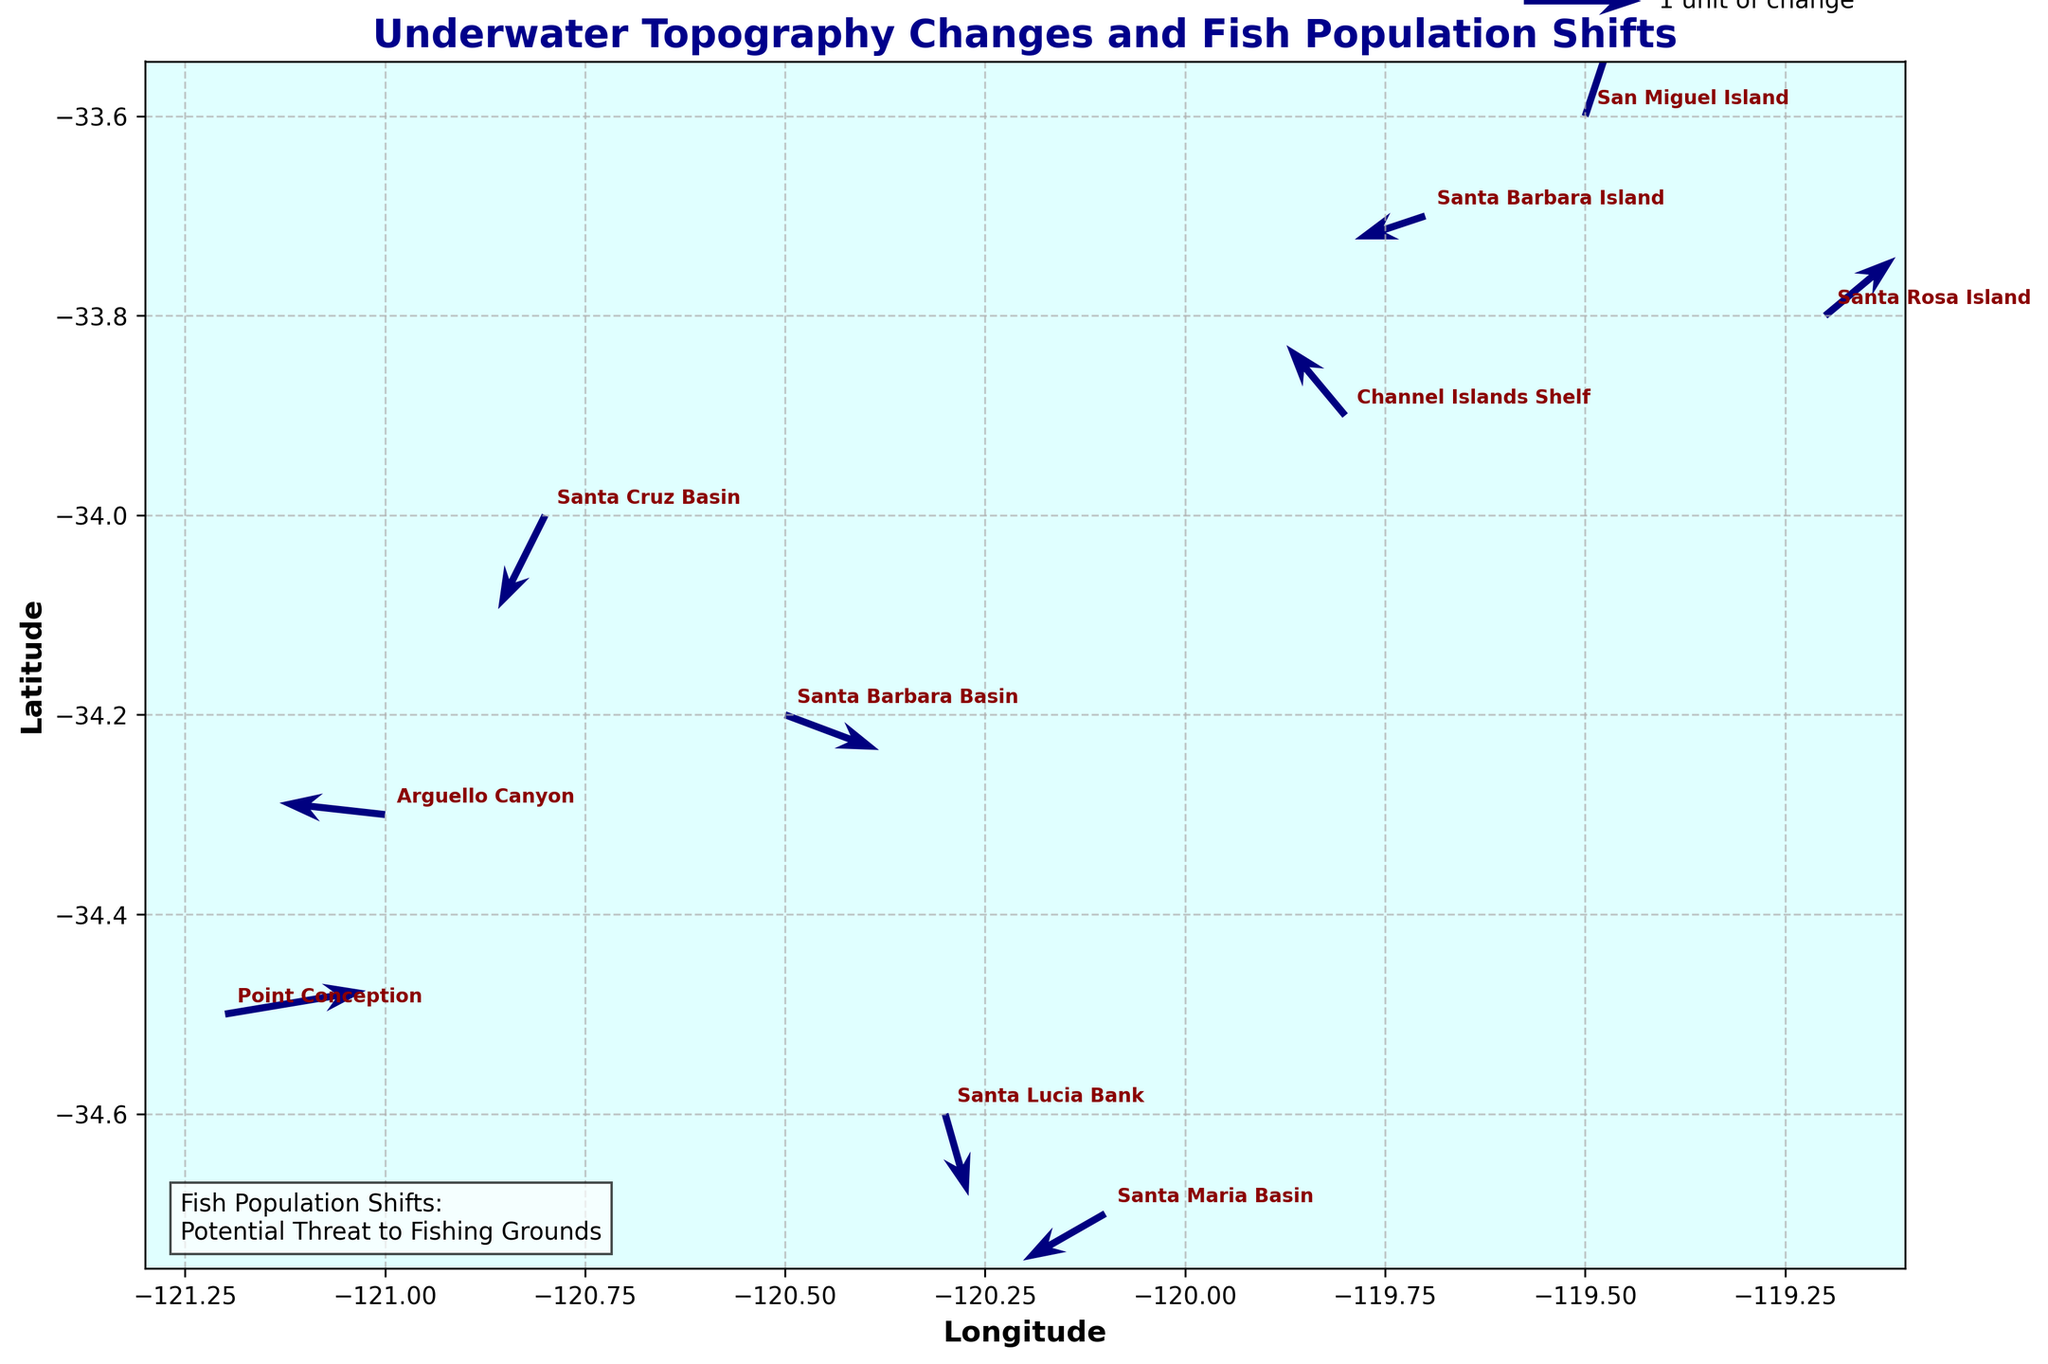What is the title of the quiver plot? The title is located at the top of the figure and reads "Underwater Topography Changes and Fish Population Shifts".
Answer: Underwater Topography Changes and Fish Population Shifts How many unique locations are annotated on the plot? The locations are marked next to the quivers and include: Santa Barbara Basin, Channel Islands Shelf, Point Conception, Santa Maria Basin, San Miguel Island, Santa Cruz Basin, Santa Rosa Island, Arguello Canyon, Santa Lucia Bank, and Santa Barbara Island.
Answer: 10 Which location shows the highest positive change in fish population along the x-axis? By observing the quivers, Point Conception has the largest positive u component (1.2) along the x-axis.
Answer: Point Conception At which location does the fish population shift show a predominant movement towards the southeast? The predominant southeast shift can be identified where both u and v components are negative. Santa Cruz Basin has a quiver pointing in that direction with u = -0.4 and v = -0.8.
Answer: Santa Cruz Basin Compare the direction of fish population shifts between Arguello Canyon and Channel Islands Shelf. Which one shows a more positive change along the y-axis? Arguello Canyon has a vector with v = 0.1 while Channel Islands Shelf has v = 0.6. Therefore, Channel Islands Shelf shows a more positive change along the y-axis.
Answer: Channel Islands Shelf What is the general trend in fish population movement at Santa Rosa Island and Santa Barbara Island? Santa Rosa Island shows a northeast movement (positive u and v), while Santa Barbara Island shows a southwest movement (negative u and v).
Answer: Northeast at Santa Rosa Island, southwest at Santa Barbara Island If you average the u-component values for all the locations, what would be the result? The u-component values are: 0.8, -0.5, 1.2, -0.7, 0.3, -0.4, 0.6, -0.9, 0.2, -0.6. The sum is 0.0, so averaging it over 10 locations results in 0.0/10 = 0.0.
Answer: 0.0 Which location has a fish population shift whose direction is closest to the north? North corresponds to a positive y-component with u close to 0. San Miguel Island has u = 0.3 and v = 0.9, closest to the north.
Answer: San Miguel Island 